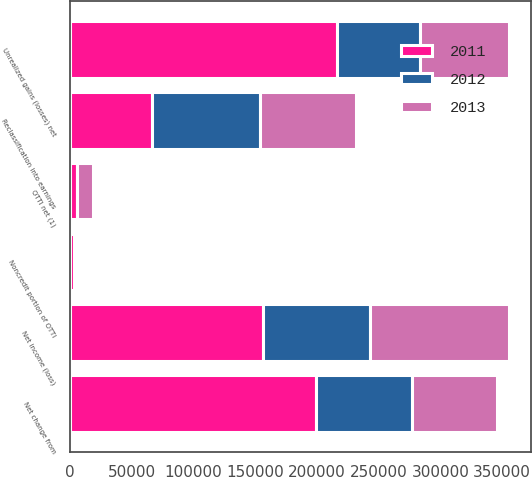Convert chart. <chart><loc_0><loc_0><loc_500><loc_500><stacked_bar_chart><ecel><fcel>Net income (loss)<fcel>OTTI net (1)<fcel>Noncredit portion of OTTI<fcel>Unrealized gains (losses) net<fcel>Reclassification into earnings<fcel>Net change from<nl><fcel>2012<fcel>86012<fcel>393<fcel>1055<fcel>67337<fcel>86894<fcel>77731<nl><fcel>2013<fcel>112583<fcel>12285<fcel>1843<fcel>72119<fcel>77731<fcel>68642<nl><fcel>2011<fcel>156701<fcel>5709<fcel>3589<fcel>216302<fcel>66847<fcel>199643<nl></chart> 